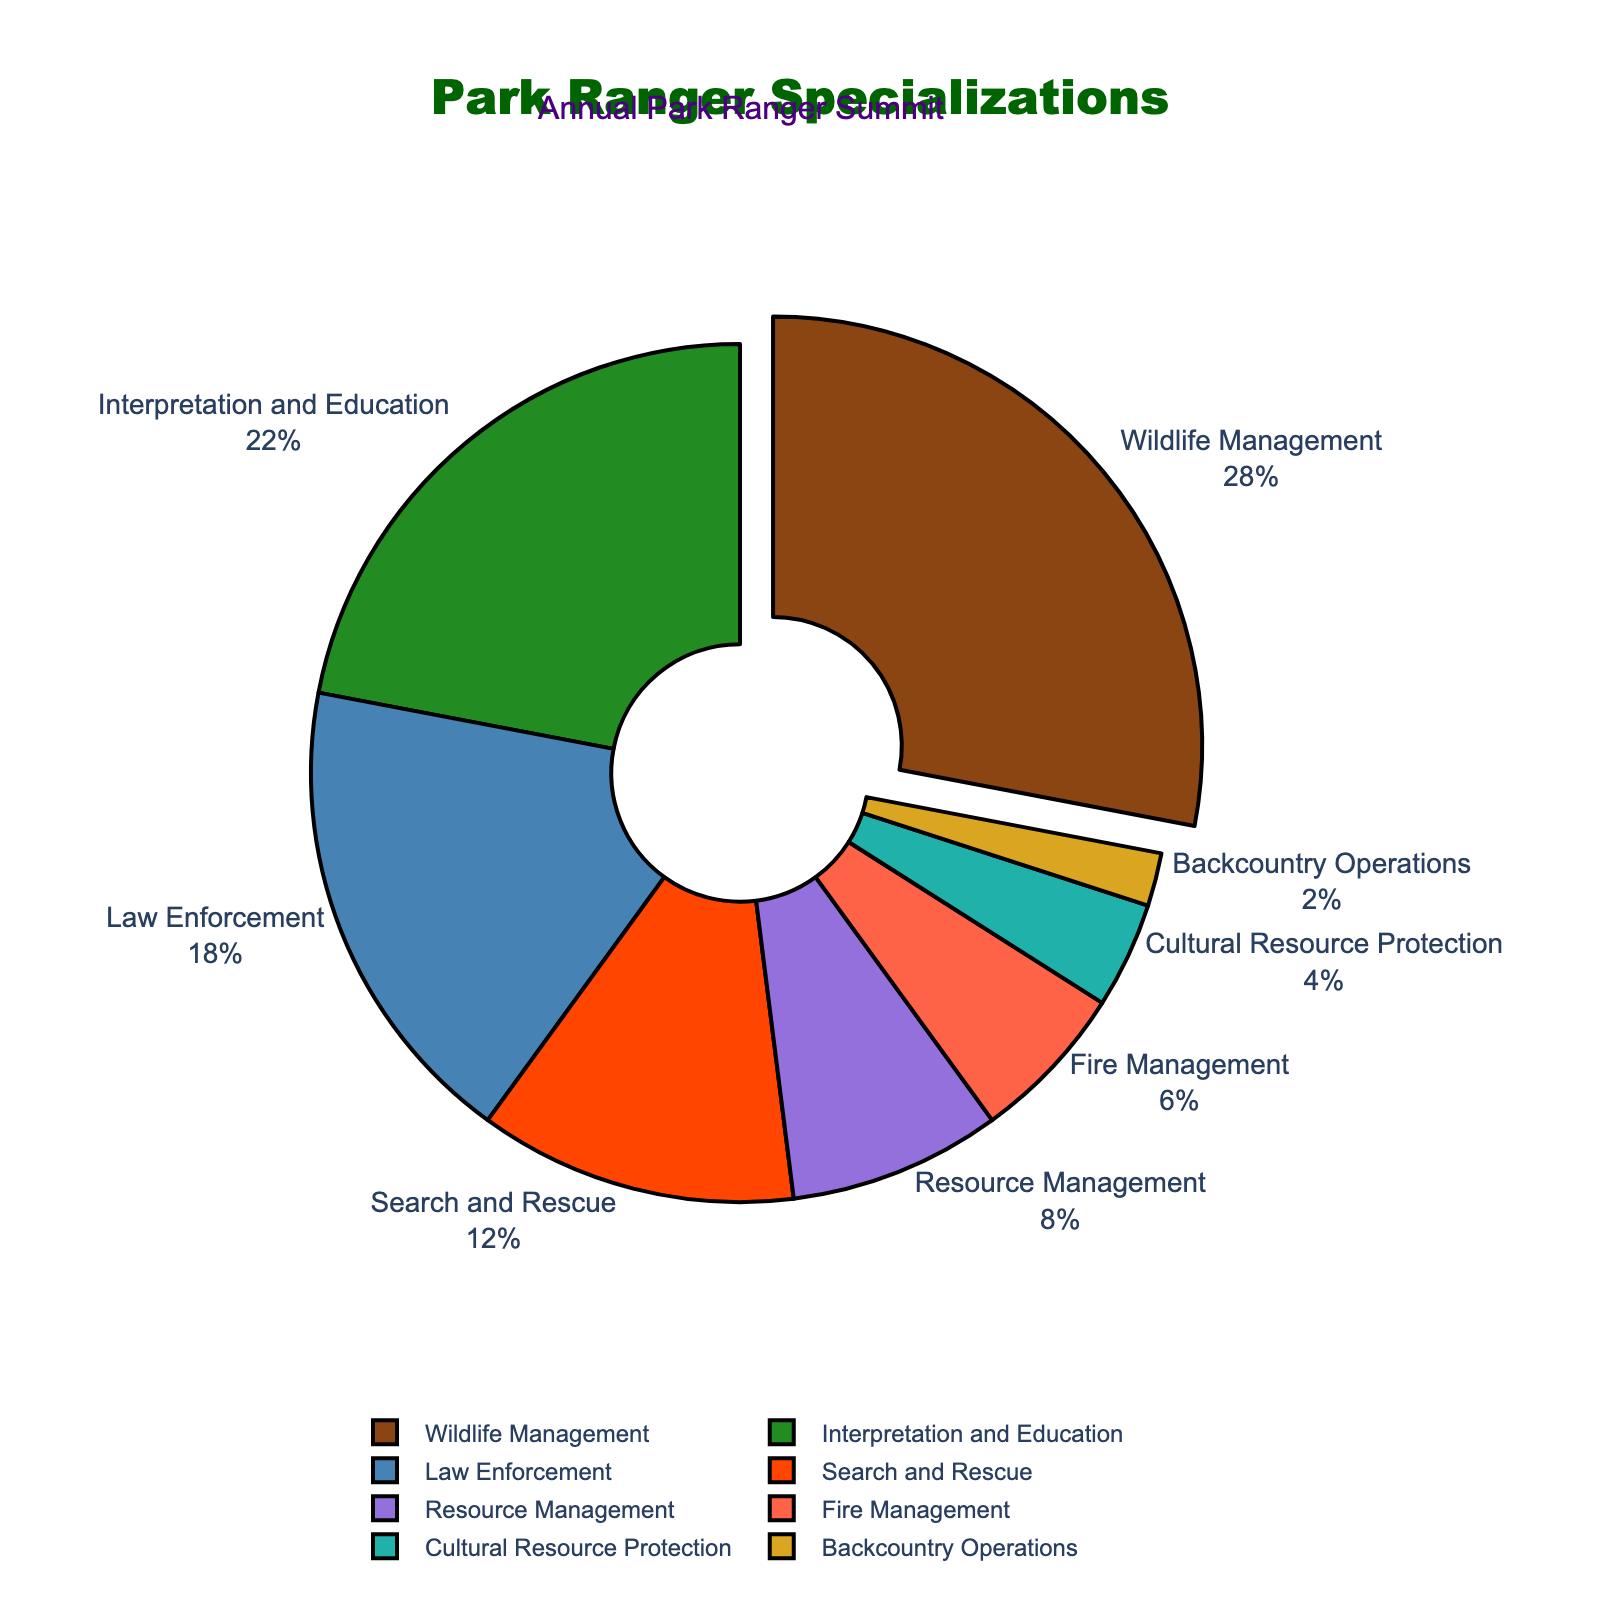What's the most common specialization among the park rangers? The figure shows that Wildlife Management has the largest segment, which is pulled slightly out from the pie. The percentage for Wildlife Management is 28%, which is the highest among all specializations.
Answer: Wildlife Management Which specialization has the smallest percentage? The smallest segment in the pie chart represents Backcountry Operations with a percentage of 2%.
Answer: Backcountry Operations What is the combined percentage of park rangers specializing in Interpretation and Education, and Search and Rescue? The percentages for Interpretation and Education and Search and Rescue are 22% and 12%, respectively. Adding them together: 22% + 12% = 34%.
Answer: 34% How much larger is the percentage of park rangers in Law Enforcement compared to those in Fire Management? Law Enforcement has a percentage of 18%, while Fire Management has 6%. Subtracting these: 18% - 6% = 12%.
Answer: 12% What is the visual difference between the segments for Wildlife Management and Cultural Resource Protection? The Wildlife Management segment is more than six times larger than the Cultural Resource Protection segment. The Wildlife Management segment is also visually emphasized by being pulled out from the pie chart.
Answer: Wildlife Management is much larger and pulled out What total percentage of park rangers is dedicated to managing resources, including both Resource Management and Fire Management? Resource Management has a percentage of 8%, and Fire Management has 6%. Adding these together: 8% + 6% = 14%.
Answer: 14% Are there more park rangers specializing in Law Enforcement or in Search and Rescue? Law Enforcement has 18%, and Search and Rescue has 12%. Since 18% is greater than 12%, there are more in Law Enforcement.
Answer: Law Enforcement Which segment represents 6% of the park ranger specializations, and how is it represented visually? The segment representing 6% is Fire Management. Visually, it is shown as a smaller segment compared to most other specializations on the pie chart.
Answer: Fire Management What is the average percentage of park rangers specializing in Interpretation and Education, and in Search and Rescue? Interpretation and Education accounts for 22% and Search and Rescue accounts for 12%. The average is: (22% + 12%) / 2 = 34% / 2 = 17%.
Answer: 17% How does the percentage of rangers in Backcountry Operations compare to those in Resource Management? Backcountry Operations is 2%, while Resource Management is 8%. The difference is 8% - 2% = 6%, with Resource Management being the larger segment.
Answer: Resource Management is 6% more 